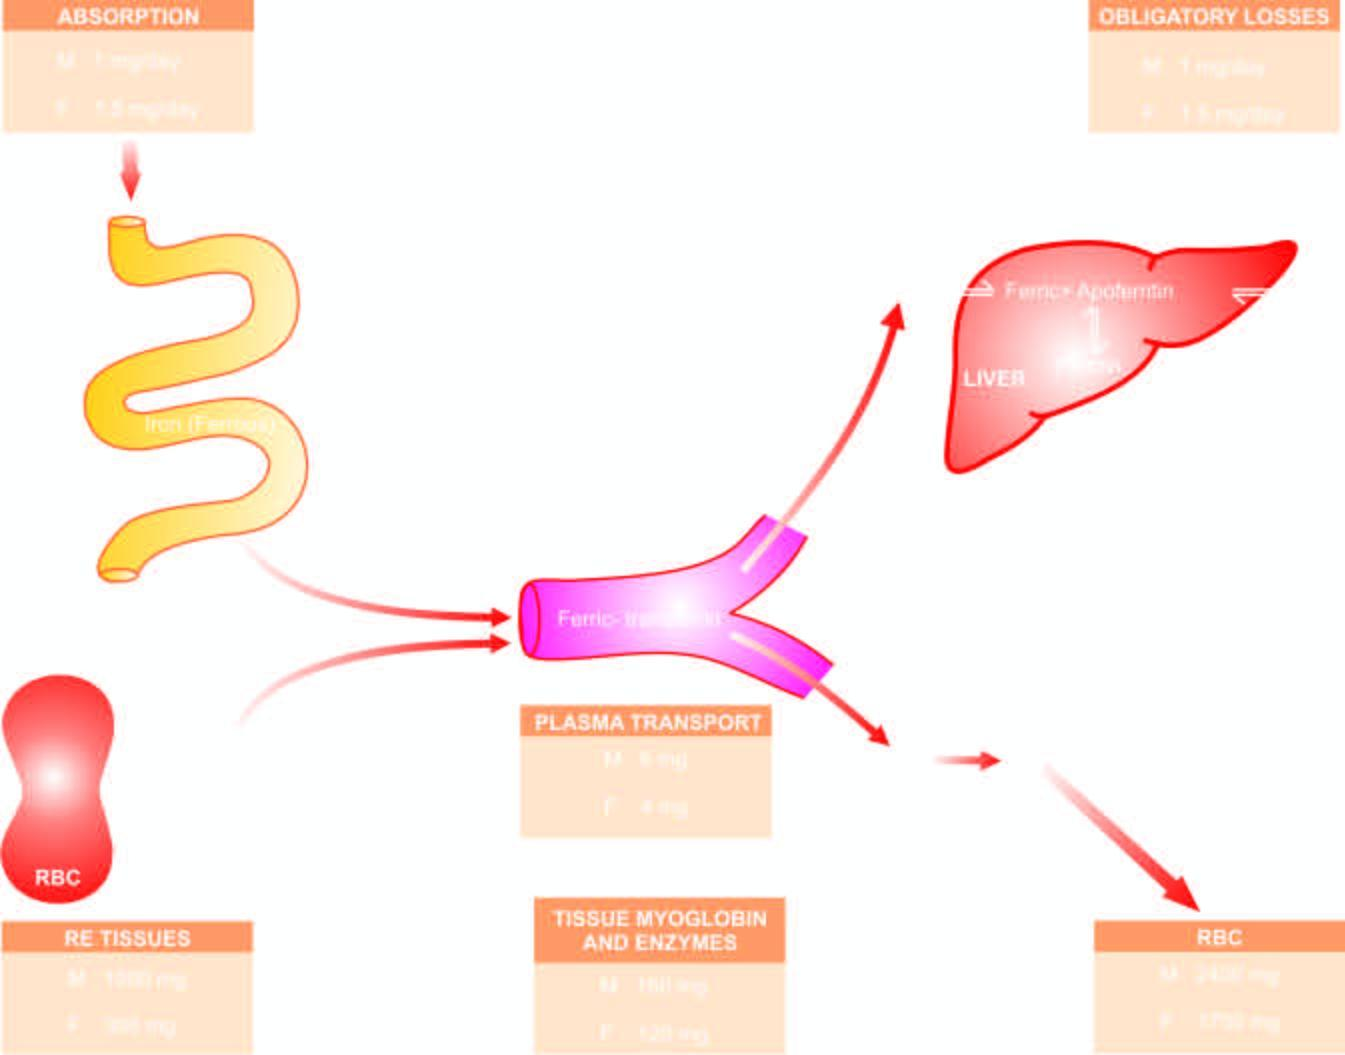re the alveolar capillaries released into circulation, which on completion of their lifespan of 120 days, die?
Answer the question using a single word or phrase. No 